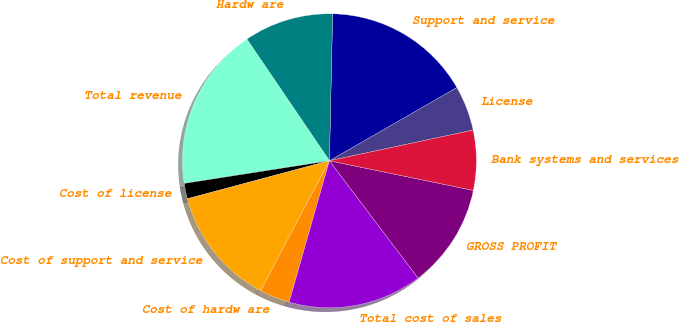Convert chart. <chart><loc_0><loc_0><loc_500><loc_500><pie_chart><fcel>License<fcel>Support and service<fcel>Hardw are<fcel>Total revenue<fcel>Cost of license<fcel>Cost of support and service<fcel>Cost of hardw are<fcel>Total cost of sales<fcel>GROSS PROFIT<fcel>Bank systems and services<nl><fcel>4.96%<fcel>16.35%<fcel>9.84%<fcel>17.97%<fcel>1.7%<fcel>13.09%<fcel>3.33%<fcel>14.72%<fcel>11.46%<fcel>6.58%<nl></chart> 